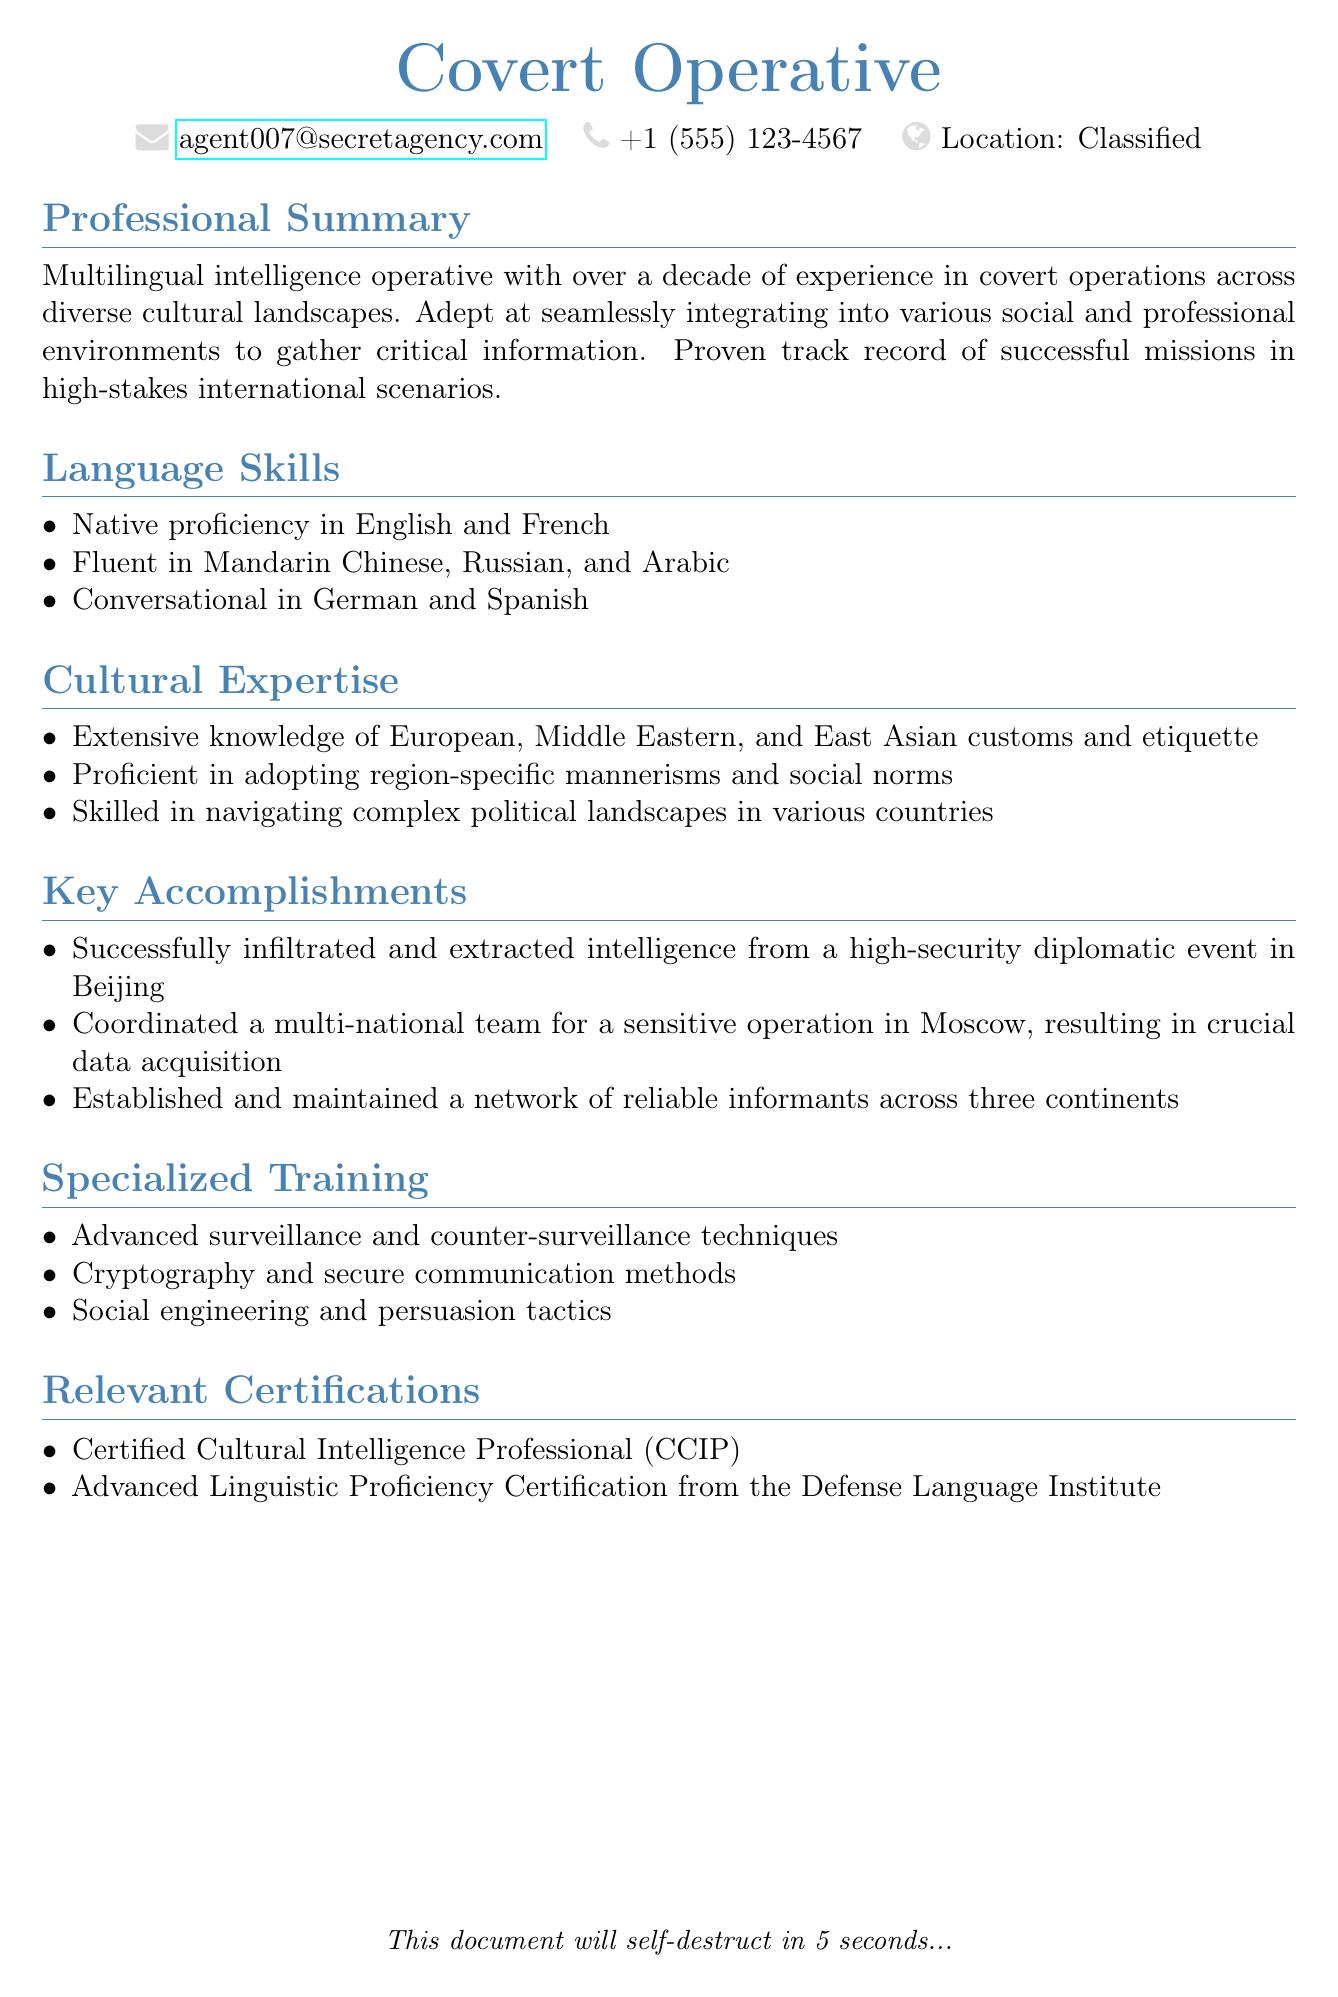What is the primary role of the individual? The document describes the individual primarily as a "Covert Operative."
Answer: Covert Operative How many languages is the individual fluent in? The individual lists being fluent in four languages: Mandarin Chinese, Russian, and Arabic.
Answer: 4 What certification does the individual hold related to cultural intelligence? The document mentions the "Certified Cultural Intelligence Professional (CCIP)" as a relevant certification.
Answer: Certified Cultural Intelligence Professional (CCIP) In which city did the individual successfully infiltrate a high-security event? The document states that the infiltration occurred at a high-security diplomatic event in Beijing.
Answer: Beijing How many years of experience does the individual have in covert operations? The document notes that the individual has over a decade of experience in covert operations.
Answer: Over a decade Which language is the individual conversational in? The document mentions that the individual is conversational in both German and Spanish.
Answer: German and Spanish What type of techniques is the individual trained in related to surveillance? The document specifies "Advanced surveillance and counter-surveillance techniques" as part of the individual's specialized training.
Answer: Advanced surveillance and counter-surveillance techniques How many continents does the individual maintain a network of informants across? The document states that the individual established a network of reliable informants across three continents.
Answer: Three continents What is one of the specialized training areas mentioned? The document lists "Social engineering and persuasion tactics" as a specialized training area.
Answer: Social engineering and persuasion tactics 